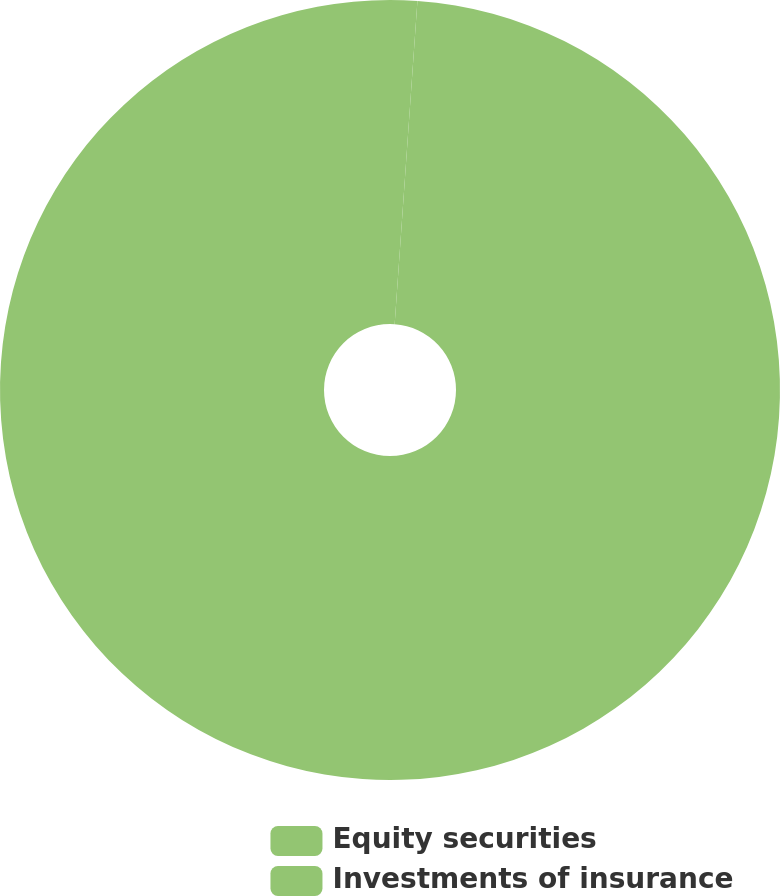Convert chart. <chart><loc_0><loc_0><loc_500><loc_500><pie_chart><fcel>Equity securities<fcel>Investments of insurance<nl><fcel>1.12%<fcel>98.88%<nl></chart> 